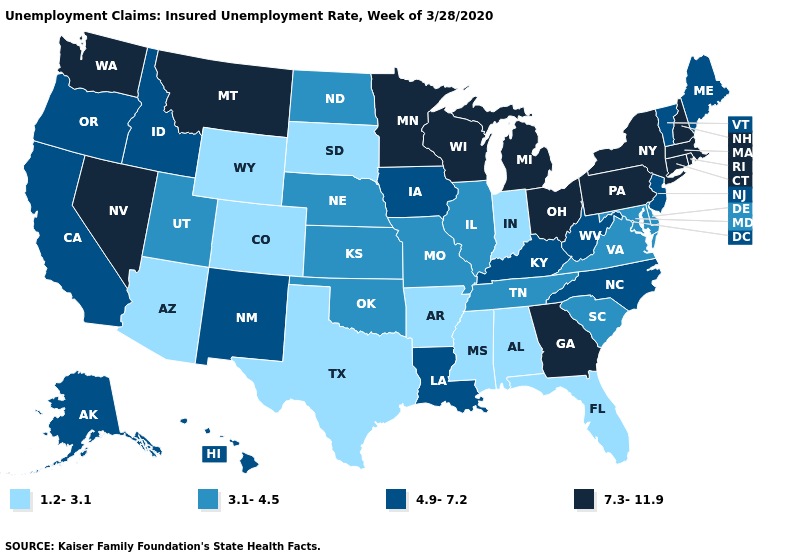Does Maryland have the lowest value in the South?
Quick response, please. No. What is the value of Colorado?
Quick response, please. 1.2-3.1. Name the states that have a value in the range 7.3-11.9?
Give a very brief answer. Connecticut, Georgia, Massachusetts, Michigan, Minnesota, Montana, Nevada, New Hampshire, New York, Ohio, Pennsylvania, Rhode Island, Washington, Wisconsin. Name the states that have a value in the range 1.2-3.1?
Write a very short answer. Alabama, Arizona, Arkansas, Colorado, Florida, Indiana, Mississippi, South Dakota, Texas, Wyoming. Does Missouri have the same value as Rhode Island?
Give a very brief answer. No. Among the states that border New Mexico , does Arizona have the highest value?
Give a very brief answer. No. What is the highest value in states that border Texas?
Be succinct. 4.9-7.2. Does Missouri have the same value as Wisconsin?
Keep it brief. No. Does Kansas have the same value as Michigan?
Give a very brief answer. No. Name the states that have a value in the range 4.9-7.2?
Answer briefly. Alaska, California, Hawaii, Idaho, Iowa, Kentucky, Louisiana, Maine, New Jersey, New Mexico, North Carolina, Oregon, Vermont, West Virginia. What is the value of Texas?
Concise answer only. 1.2-3.1. Name the states that have a value in the range 3.1-4.5?
Answer briefly. Delaware, Illinois, Kansas, Maryland, Missouri, Nebraska, North Dakota, Oklahoma, South Carolina, Tennessee, Utah, Virginia. Among the states that border South Carolina , does North Carolina have the lowest value?
Write a very short answer. Yes. Does Montana have the highest value in the West?
Be succinct. Yes. What is the lowest value in the USA?
Give a very brief answer. 1.2-3.1. 